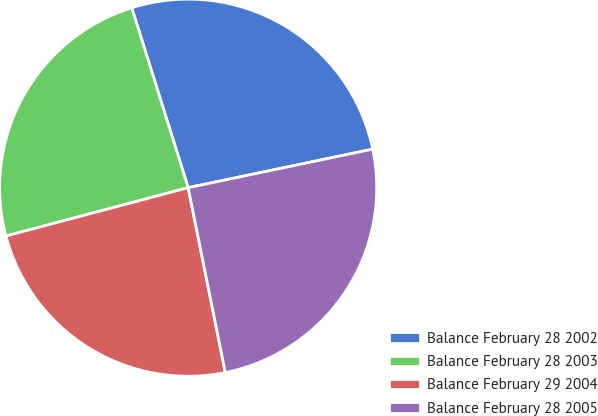Convert chart to OTSL. <chart><loc_0><loc_0><loc_500><loc_500><pie_chart><fcel>Balance February 28 2002<fcel>Balance February 28 2003<fcel>Balance February 29 2004<fcel>Balance February 28 2005<nl><fcel>26.56%<fcel>24.29%<fcel>24.03%<fcel>25.12%<nl></chart> 